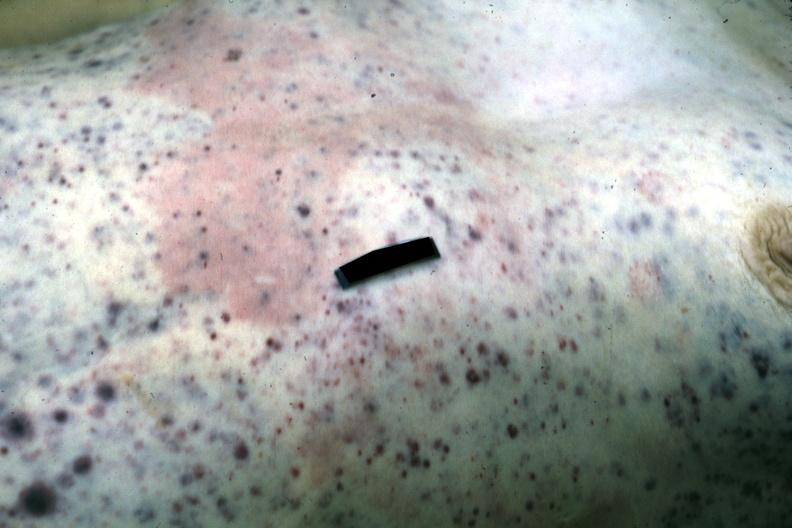what does this image show?
Answer the question using a single word or phrase. But not good color petechiae and purpura case of stcell leukemia 